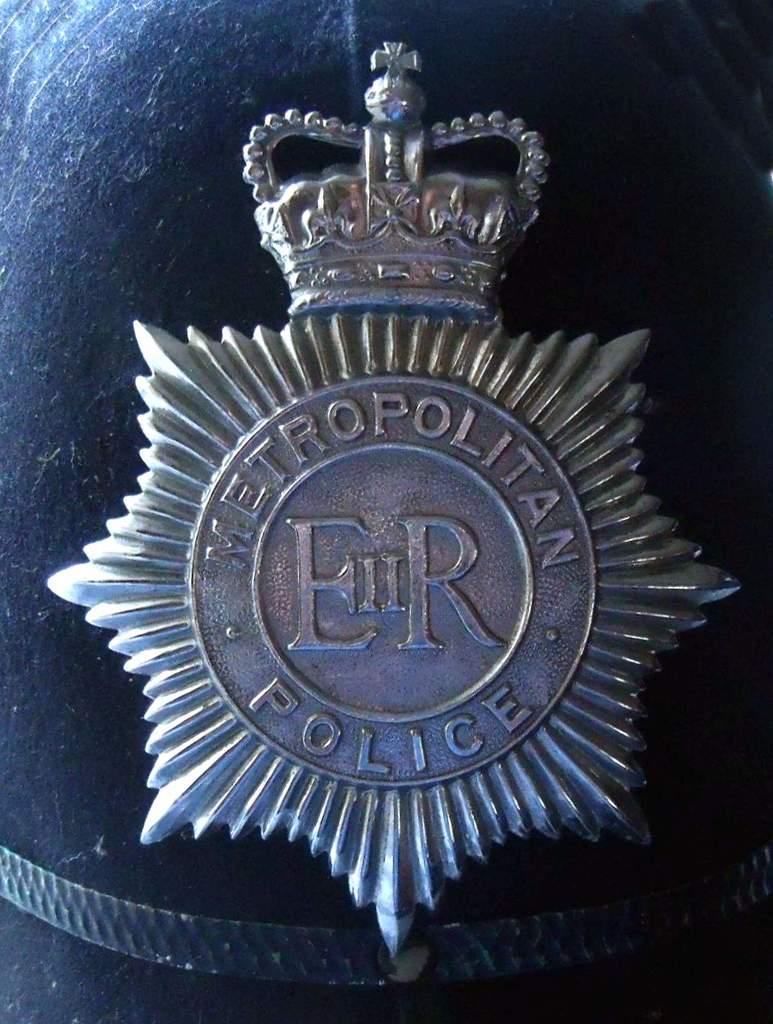What two letters are in the middle of the badge?
Offer a very short reply. Er. 